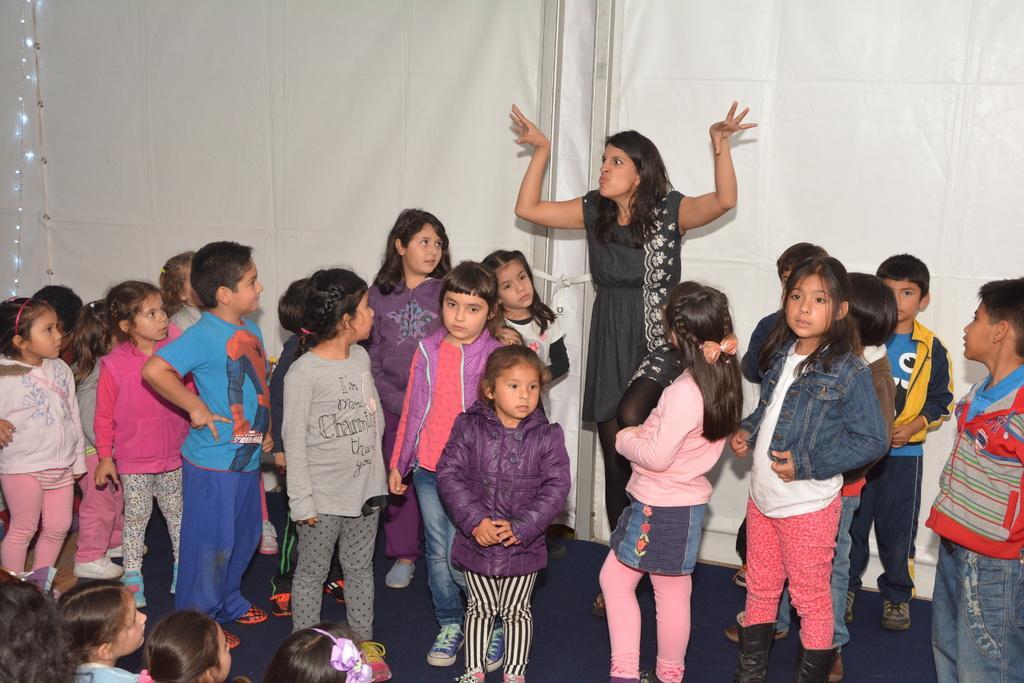Describe this image in one or two sentences. In this image, we can see children and there is a lady. In the background, there are lights and we can see a board. At the bottom, there is floor. 